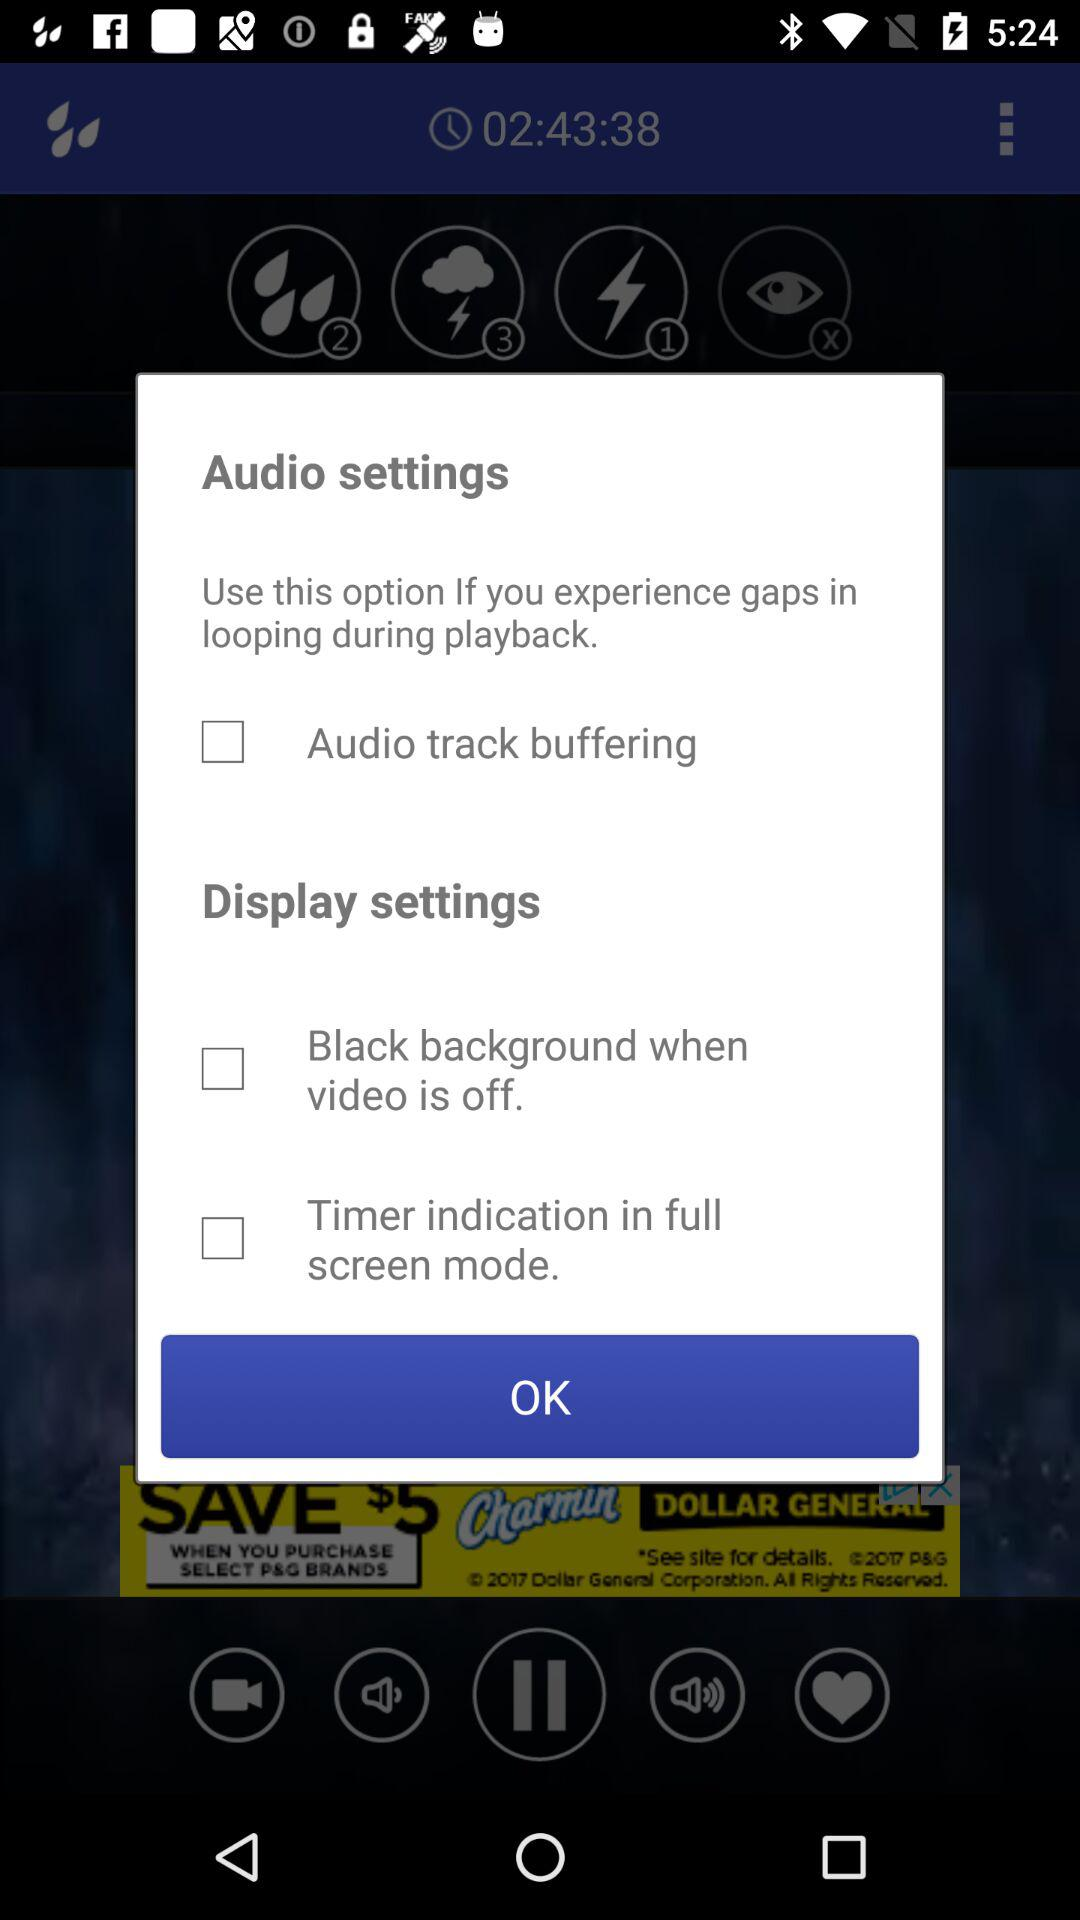How many more checkboxes are there in the display settings section than in the audio settings section?
Answer the question using a single word or phrase. 1 